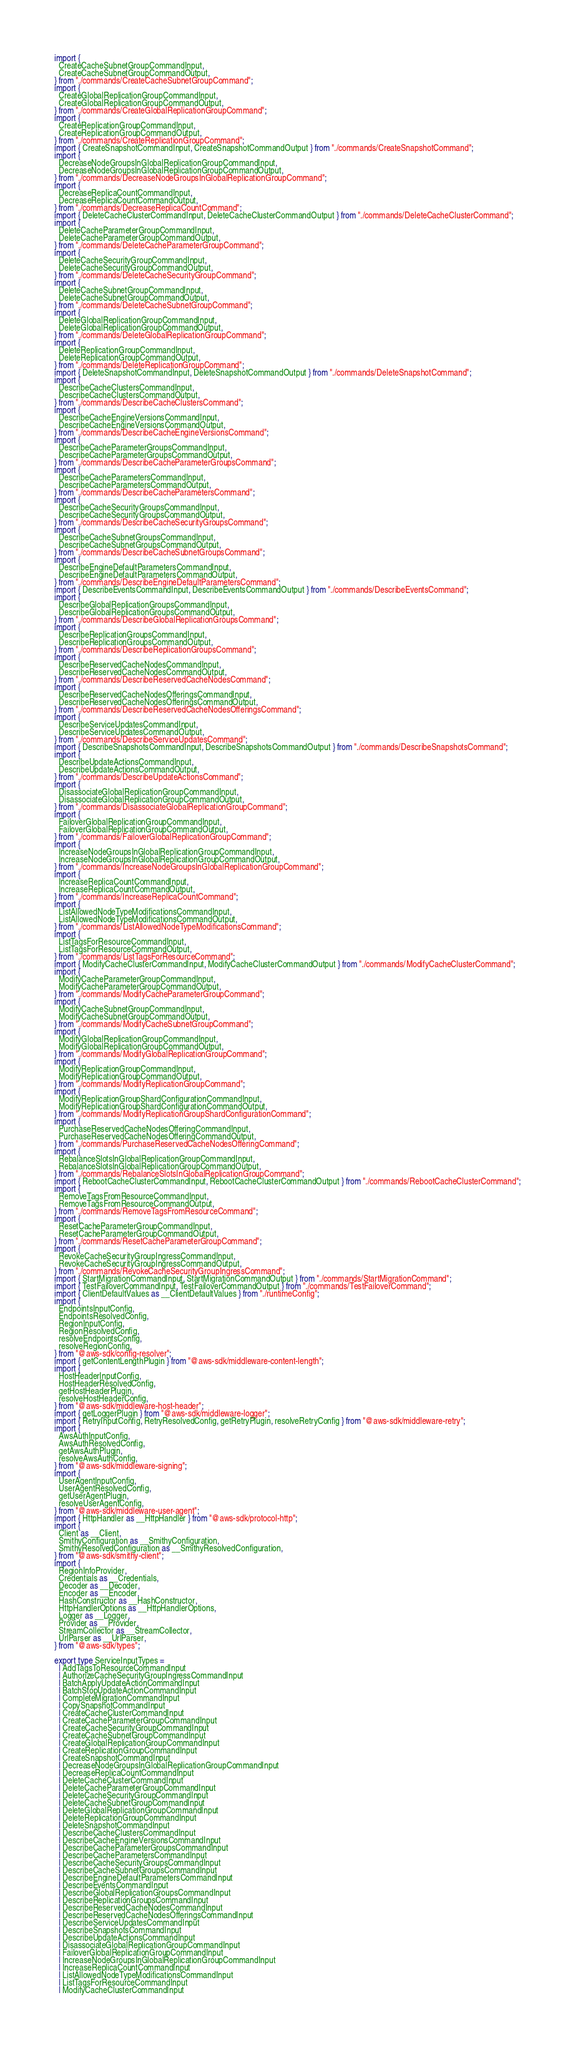Convert code to text. <code><loc_0><loc_0><loc_500><loc_500><_TypeScript_>import {
  CreateCacheSubnetGroupCommandInput,
  CreateCacheSubnetGroupCommandOutput,
} from "./commands/CreateCacheSubnetGroupCommand";
import {
  CreateGlobalReplicationGroupCommandInput,
  CreateGlobalReplicationGroupCommandOutput,
} from "./commands/CreateGlobalReplicationGroupCommand";
import {
  CreateReplicationGroupCommandInput,
  CreateReplicationGroupCommandOutput,
} from "./commands/CreateReplicationGroupCommand";
import { CreateSnapshotCommandInput, CreateSnapshotCommandOutput } from "./commands/CreateSnapshotCommand";
import {
  DecreaseNodeGroupsInGlobalReplicationGroupCommandInput,
  DecreaseNodeGroupsInGlobalReplicationGroupCommandOutput,
} from "./commands/DecreaseNodeGroupsInGlobalReplicationGroupCommand";
import {
  DecreaseReplicaCountCommandInput,
  DecreaseReplicaCountCommandOutput,
} from "./commands/DecreaseReplicaCountCommand";
import { DeleteCacheClusterCommandInput, DeleteCacheClusterCommandOutput } from "./commands/DeleteCacheClusterCommand";
import {
  DeleteCacheParameterGroupCommandInput,
  DeleteCacheParameterGroupCommandOutput,
} from "./commands/DeleteCacheParameterGroupCommand";
import {
  DeleteCacheSecurityGroupCommandInput,
  DeleteCacheSecurityGroupCommandOutput,
} from "./commands/DeleteCacheSecurityGroupCommand";
import {
  DeleteCacheSubnetGroupCommandInput,
  DeleteCacheSubnetGroupCommandOutput,
} from "./commands/DeleteCacheSubnetGroupCommand";
import {
  DeleteGlobalReplicationGroupCommandInput,
  DeleteGlobalReplicationGroupCommandOutput,
} from "./commands/DeleteGlobalReplicationGroupCommand";
import {
  DeleteReplicationGroupCommandInput,
  DeleteReplicationGroupCommandOutput,
} from "./commands/DeleteReplicationGroupCommand";
import { DeleteSnapshotCommandInput, DeleteSnapshotCommandOutput } from "./commands/DeleteSnapshotCommand";
import {
  DescribeCacheClustersCommandInput,
  DescribeCacheClustersCommandOutput,
} from "./commands/DescribeCacheClustersCommand";
import {
  DescribeCacheEngineVersionsCommandInput,
  DescribeCacheEngineVersionsCommandOutput,
} from "./commands/DescribeCacheEngineVersionsCommand";
import {
  DescribeCacheParameterGroupsCommandInput,
  DescribeCacheParameterGroupsCommandOutput,
} from "./commands/DescribeCacheParameterGroupsCommand";
import {
  DescribeCacheParametersCommandInput,
  DescribeCacheParametersCommandOutput,
} from "./commands/DescribeCacheParametersCommand";
import {
  DescribeCacheSecurityGroupsCommandInput,
  DescribeCacheSecurityGroupsCommandOutput,
} from "./commands/DescribeCacheSecurityGroupsCommand";
import {
  DescribeCacheSubnetGroupsCommandInput,
  DescribeCacheSubnetGroupsCommandOutput,
} from "./commands/DescribeCacheSubnetGroupsCommand";
import {
  DescribeEngineDefaultParametersCommandInput,
  DescribeEngineDefaultParametersCommandOutput,
} from "./commands/DescribeEngineDefaultParametersCommand";
import { DescribeEventsCommandInput, DescribeEventsCommandOutput } from "./commands/DescribeEventsCommand";
import {
  DescribeGlobalReplicationGroupsCommandInput,
  DescribeGlobalReplicationGroupsCommandOutput,
} from "./commands/DescribeGlobalReplicationGroupsCommand";
import {
  DescribeReplicationGroupsCommandInput,
  DescribeReplicationGroupsCommandOutput,
} from "./commands/DescribeReplicationGroupsCommand";
import {
  DescribeReservedCacheNodesCommandInput,
  DescribeReservedCacheNodesCommandOutput,
} from "./commands/DescribeReservedCacheNodesCommand";
import {
  DescribeReservedCacheNodesOfferingsCommandInput,
  DescribeReservedCacheNodesOfferingsCommandOutput,
} from "./commands/DescribeReservedCacheNodesOfferingsCommand";
import {
  DescribeServiceUpdatesCommandInput,
  DescribeServiceUpdatesCommandOutput,
} from "./commands/DescribeServiceUpdatesCommand";
import { DescribeSnapshotsCommandInput, DescribeSnapshotsCommandOutput } from "./commands/DescribeSnapshotsCommand";
import {
  DescribeUpdateActionsCommandInput,
  DescribeUpdateActionsCommandOutput,
} from "./commands/DescribeUpdateActionsCommand";
import {
  DisassociateGlobalReplicationGroupCommandInput,
  DisassociateGlobalReplicationGroupCommandOutput,
} from "./commands/DisassociateGlobalReplicationGroupCommand";
import {
  FailoverGlobalReplicationGroupCommandInput,
  FailoverGlobalReplicationGroupCommandOutput,
} from "./commands/FailoverGlobalReplicationGroupCommand";
import {
  IncreaseNodeGroupsInGlobalReplicationGroupCommandInput,
  IncreaseNodeGroupsInGlobalReplicationGroupCommandOutput,
} from "./commands/IncreaseNodeGroupsInGlobalReplicationGroupCommand";
import {
  IncreaseReplicaCountCommandInput,
  IncreaseReplicaCountCommandOutput,
} from "./commands/IncreaseReplicaCountCommand";
import {
  ListAllowedNodeTypeModificationsCommandInput,
  ListAllowedNodeTypeModificationsCommandOutput,
} from "./commands/ListAllowedNodeTypeModificationsCommand";
import {
  ListTagsForResourceCommandInput,
  ListTagsForResourceCommandOutput,
} from "./commands/ListTagsForResourceCommand";
import { ModifyCacheClusterCommandInput, ModifyCacheClusterCommandOutput } from "./commands/ModifyCacheClusterCommand";
import {
  ModifyCacheParameterGroupCommandInput,
  ModifyCacheParameterGroupCommandOutput,
} from "./commands/ModifyCacheParameterGroupCommand";
import {
  ModifyCacheSubnetGroupCommandInput,
  ModifyCacheSubnetGroupCommandOutput,
} from "./commands/ModifyCacheSubnetGroupCommand";
import {
  ModifyGlobalReplicationGroupCommandInput,
  ModifyGlobalReplicationGroupCommandOutput,
} from "./commands/ModifyGlobalReplicationGroupCommand";
import {
  ModifyReplicationGroupCommandInput,
  ModifyReplicationGroupCommandOutput,
} from "./commands/ModifyReplicationGroupCommand";
import {
  ModifyReplicationGroupShardConfigurationCommandInput,
  ModifyReplicationGroupShardConfigurationCommandOutput,
} from "./commands/ModifyReplicationGroupShardConfigurationCommand";
import {
  PurchaseReservedCacheNodesOfferingCommandInput,
  PurchaseReservedCacheNodesOfferingCommandOutput,
} from "./commands/PurchaseReservedCacheNodesOfferingCommand";
import {
  RebalanceSlotsInGlobalReplicationGroupCommandInput,
  RebalanceSlotsInGlobalReplicationGroupCommandOutput,
} from "./commands/RebalanceSlotsInGlobalReplicationGroupCommand";
import { RebootCacheClusterCommandInput, RebootCacheClusterCommandOutput } from "./commands/RebootCacheClusterCommand";
import {
  RemoveTagsFromResourceCommandInput,
  RemoveTagsFromResourceCommandOutput,
} from "./commands/RemoveTagsFromResourceCommand";
import {
  ResetCacheParameterGroupCommandInput,
  ResetCacheParameterGroupCommandOutput,
} from "./commands/ResetCacheParameterGroupCommand";
import {
  RevokeCacheSecurityGroupIngressCommandInput,
  RevokeCacheSecurityGroupIngressCommandOutput,
} from "./commands/RevokeCacheSecurityGroupIngressCommand";
import { StartMigrationCommandInput, StartMigrationCommandOutput } from "./commands/StartMigrationCommand";
import { TestFailoverCommandInput, TestFailoverCommandOutput } from "./commands/TestFailoverCommand";
import { ClientDefaultValues as __ClientDefaultValues } from "./runtimeConfig";
import {
  EndpointsInputConfig,
  EndpointsResolvedConfig,
  RegionInputConfig,
  RegionResolvedConfig,
  resolveEndpointsConfig,
  resolveRegionConfig,
} from "@aws-sdk/config-resolver";
import { getContentLengthPlugin } from "@aws-sdk/middleware-content-length";
import {
  HostHeaderInputConfig,
  HostHeaderResolvedConfig,
  getHostHeaderPlugin,
  resolveHostHeaderConfig,
} from "@aws-sdk/middleware-host-header";
import { getLoggerPlugin } from "@aws-sdk/middleware-logger";
import { RetryInputConfig, RetryResolvedConfig, getRetryPlugin, resolveRetryConfig } from "@aws-sdk/middleware-retry";
import {
  AwsAuthInputConfig,
  AwsAuthResolvedConfig,
  getAwsAuthPlugin,
  resolveAwsAuthConfig,
} from "@aws-sdk/middleware-signing";
import {
  UserAgentInputConfig,
  UserAgentResolvedConfig,
  getUserAgentPlugin,
  resolveUserAgentConfig,
} from "@aws-sdk/middleware-user-agent";
import { HttpHandler as __HttpHandler } from "@aws-sdk/protocol-http";
import {
  Client as __Client,
  SmithyConfiguration as __SmithyConfiguration,
  SmithyResolvedConfiguration as __SmithyResolvedConfiguration,
} from "@aws-sdk/smithy-client";
import {
  RegionInfoProvider,
  Credentials as __Credentials,
  Decoder as __Decoder,
  Encoder as __Encoder,
  HashConstructor as __HashConstructor,
  HttpHandlerOptions as __HttpHandlerOptions,
  Logger as __Logger,
  Provider as __Provider,
  StreamCollector as __StreamCollector,
  UrlParser as __UrlParser,
} from "@aws-sdk/types";

export type ServiceInputTypes =
  | AddTagsToResourceCommandInput
  | AuthorizeCacheSecurityGroupIngressCommandInput
  | BatchApplyUpdateActionCommandInput
  | BatchStopUpdateActionCommandInput
  | CompleteMigrationCommandInput
  | CopySnapshotCommandInput
  | CreateCacheClusterCommandInput
  | CreateCacheParameterGroupCommandInput
  | CreateCacheSecurityGroupCommandInput
  | CreateCacheSubnetGroupCommandInput
  | CreateGlobalReplicationGroupCommandInput
  | CreateReplicationGroupCommandInput
  | CreateSnapshotCommandInput
  | DecreaseNodeGroupsInGlobalReplicationGroupCommandInput
  | DecreaseReplicaCountCommandInput
  | DeleteCacheClusterCommandInput
  | DeleteCacheParameterGroupCommandInput
  | DeleteCacheSecurityGroupCommandInput
  | DeleteCacheSubnetGroupCommandInput
  | DeleteGlobalReplicationGroupCommandInput
  | DeleteReplicationGroupCommandInput
  | DeleteSnapshotCommandInput
  | DescribeCacheClustersCommandInput
  | DescribeCacheEngineVersionsCommandInput
  | DescribeCacheParameterGroupsCommandInput
  | DescribeCacheParametersCommandInput
  | DescribeCacheSecurityGroupsCommandInput
  | DescribeCacheSubnetGroupsCommandInput
  | DescribeEngineDefaultParametersCommandInput
  | DescribeEventsCommandInput
  | DescribeGlobalReplicationGroupsCommandInput
  | DescribeReplicationGroupsCommandInput
  | DescribeReservedCacheNodesCommandInput
  | DescribeReservedCacheNodesOfferingsCommandInput
  | DescribeServiceUpdatesCommandInput
  | DescribeSnapshotsCommandInput
  | DescribeUpdateActionsCommandInput
  | DisassociateGlobalReplicationGroupCommandInput
  | FailoverGlobalReplicationGroupCommandInput
  | IncreaseNodeGroupsInGlobalReplicationGroupCommandInput
  | IncreaseReplicaCountCommandInput
  | ListAllowedNodeTypeModificationsCommandInput
  | ListTagsForResourceCommandInput
  | ModifyCacheClusterCommandInput</code> 